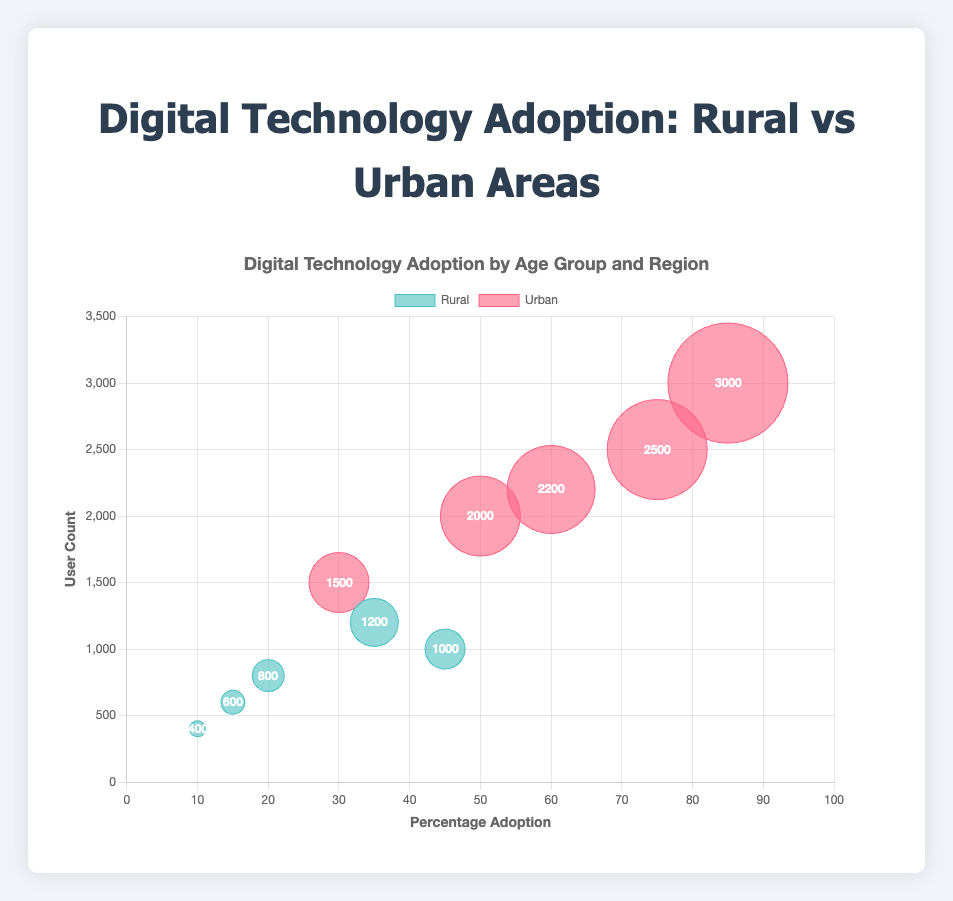What is the title of the chart? The title is located at the top of the chart and provides an overview of what the chart represents. It reads "Digital Technology Adoption by Age Group and Region".
Answer: Digital Technology Adoption by Age Group and Region Which age group has the highest percentage adoption in urban areas? By examining the x-axis (Percentage Adoption) and locating the highest point for "Urban" category, we find that the 18-25 age group has the highest percentage adoption at 85%.
Answer: 18-25 What is the percentage adoption for the age group 46-60 in rural areas? Look at the "Rural" bubbles corresponding to the 46-60 age group and refer to the x-axis for the percentage adoption, which is 15%.
Answer: 15% Which region has a higher adoption percentage for the age group 60+? Compare the bubbles for the 60+ age group in both regions. The urban bubble is at 30% adoption, while the rural bubble is at 10% adoption. Thus, urban has a higher adoption percentage for this age group.
Answer: Urban What is the user count for the 18-25 age group in rural areas? Identify the bubble marked for the 18-25 age group in rural areas and refer to its y-axis value, which shows the user count as 1200.
Answer: 1200 How many data points are shown in the chart? Count the total number of bubbles in the chart. There are 10 data points, one for each combination of age group and region.
Answer: 10 Which age group shows the greatest difference in adoption percentage between urban and rural areas? The difference can be found by subtracting the rural percentage from the urban percentage for each age group. The 18-25 age group has the highest difference: 85% (urban) - 35% (rural) = 50%.
Answer: 18-25 What is the average percentage adoption of the 36-45 age group across both regions? Find the percentages for the 36-45 age group in rural and urban areas, which are 20% and 60% respectively. Calculate the average: (20% + 60%) / 2 = 40%.
Answer: 40% Which data point represents the highest user count? The highest user count is identified by the largest bubble along the y-axis. The urban 18-25 age group has the highest user count at 3000.
Answer: Urban 18-25 What is the sum of user counts for all rural age groups? Add the user counts for each rural age group: 1200 (18-25) + 1000 (26-35) + 800 (36-45) + 600 (46-60) + 400 (60+). The sum is 4000.
Answer: 4000 